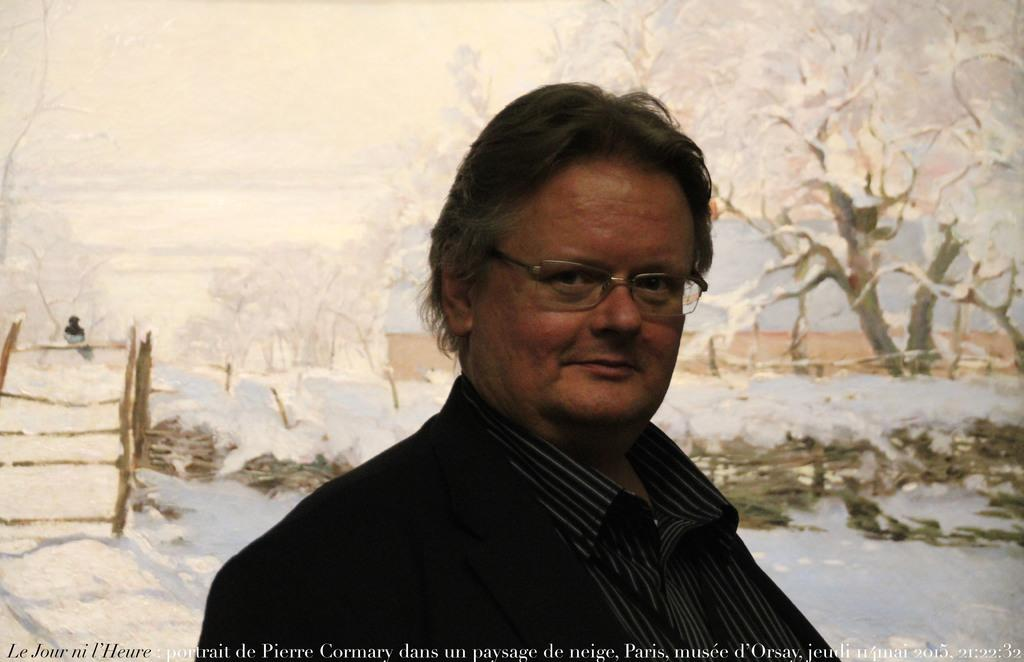What is the man in the image wearing? The man is wearing a suit. What can be seen in the background of the image? There are trees visible in the background of the image. Can you describe the bird in the image? There is a bird on a staircase in the image. What is the weather like in the image? There is snow in the image, indicating cold weather. What time of day is it in the image, considering the afternoon? The time of day cannot be determined from the image, as there is no indication of the time. 